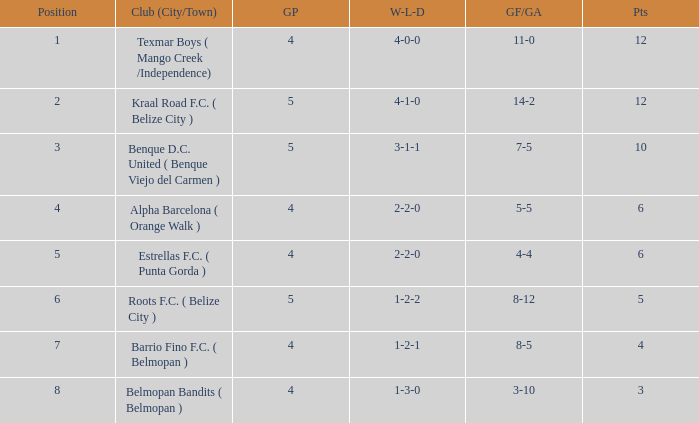Help me parse the entirety of this table. {'header': ['Position', 'Club (City/Town)', 'GP', 'W-L-D', 'GF/GA', 'Pts'], 'rows': [['1', 'Texmar Boys ( Mango Creek /Independence)', '4', '4-0-0', '11-0', '12'], ['2', 'Kraal Road F.C. ( Belize City )', '5', '4-1-0', '14-2', '12'], ['3', 'Benque D.C. United ( Benque Viejo del Carmen )', '5', '3-1-1', '7-5', '10'], ['4', 'Alpha Barcelona ( Orange Walk )', '4', '2-2-0', '5-5', '6'], ['5', 'Estrellas F.C. ( Punta Gorda )', '4', '2-2-0', '4-4', '6'], ['6', 'Roots F.C. ( Belize City )', '5', '1-2-2', '8-12', '5'], ['7', 'Barrio Fino F.C. ( Belmopan )', '4', '1-2-1', '8-5', '4'], ['8', 'Belmopan Bandits ( Belmopan )', '4', '1-3-0', '3-10', '3']]} What's the goals for/against with w-l-d being 3-1-1 7-5. 